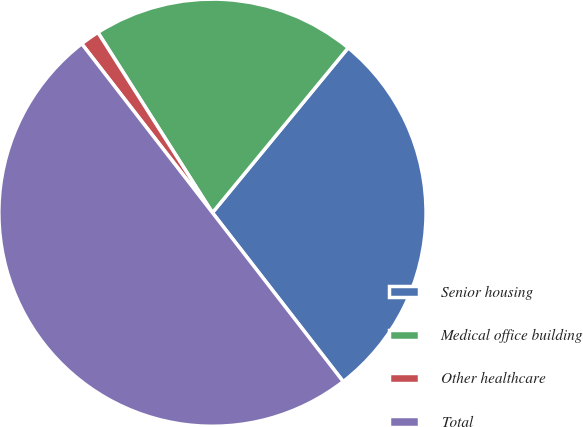Convert chart to OTSL. <chart><loc_0><loc_0><loc_500><loc_500><pie_chart><fcel>Senior housing<fcel>Medical office building<fcel>Other healthcare<fcel>Total<nl><fcel>28.55%<fcel>19.97%<fcel>1.47%<fcel>50.0%<nl></chart> 